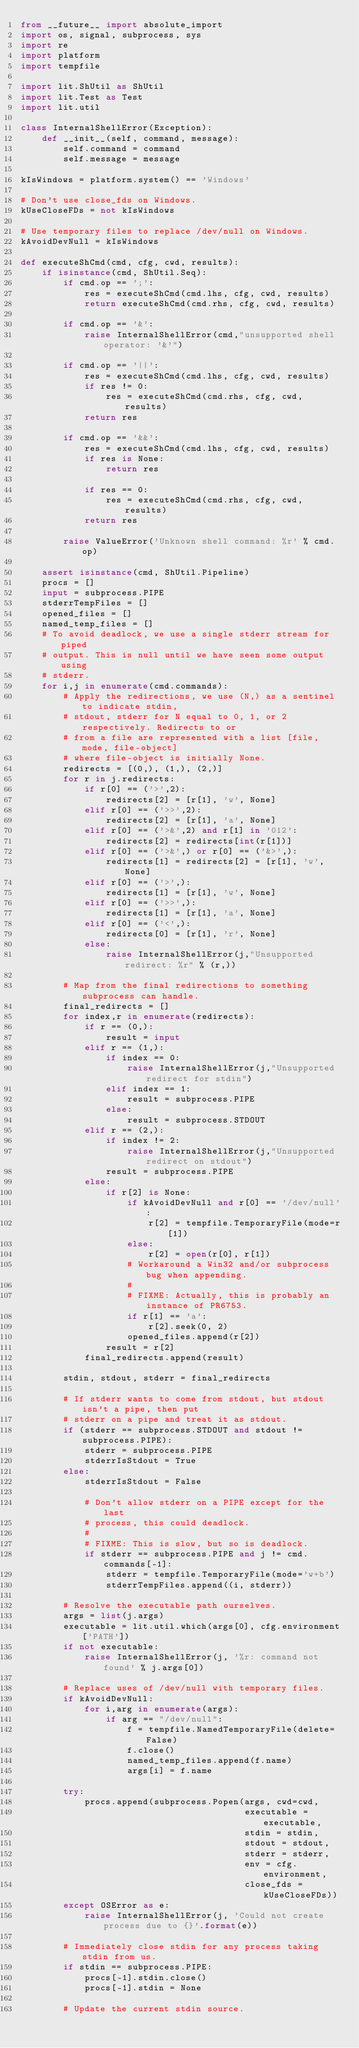<code> <loc_0><loc_0><loc_500><loc_500><_Python_>from __future__ import absolute_import
import os, signal, subprocess, sys
import re
import platform
import tempfile

import lit.ShUtil as ShUtil
import lit.Test as Test
import lit.util

class InternalShellError(Exception):
    def __init__(self, command, message):
        self.command = command
        self.message = message

kIsWindows = platform.system() == 'Windows'

# Don't use close_fds on Windows.
kUseCloseFDs = not kIsWindows

# Use temporary files to replace /dev/null on Windows.
kAvoidDevNull = kIsWindows

def executeShCmd(cmd, cfg, cwd, results):
    if isinstance(cmd, ShUtil.Seq):
        if cmd.op == ';':
            res = executeShCmd(cmd.lhs, cfg, cwd, results)
            return executeShCmd(cmd.rhs, cfg, cwd, results)

        if cmd.op == '&':
            raise InternalShellError(cmd,"unsupported shell operator: '&'")

        if cmd.op == '||':
            res = executeShCmd(cmd.lhs, cfg, cwd, results)
            if res != 0:
                res = executeShCmd(cmd.rhs, cfg, cwd, results)
            return res

        if cmd.op == '&&':
            res = executeShCmd(cmd.lhs, cfg, cwd, results)
            if res is None:
                return res

            if res == 0:
                res = executeShCmd(cmd.rhs, cfg, cwd, results)
            return res

        raise ValueError('Unknown shell command: %r' % cmd.op)

    assert isinstance(cmd, ShUtil.Pipeline)
    procs = []
    input = subprocess.PIPE
    stderrTempFiles = []
    opened_files = []
    named_temp_files = []
    # To avoid deadlock, we use a single stderr stream for piped
    # output. This is null until we have seen some output using
    # stderr.
    for i,j in enumerate(cmd.commands):
        # Apply the redirections, we use (N,) as a sentinel to indicate stdin,
        # stdout, stderr for N equal to 0, 1, or 2 respectively. Redirects to or
        # from a file are represented with a list [file, mode, file-object]
        # where file-object is initially None.
        redirects = [(0,), (1,), (2,)]
        for r in j.redirects:
            if r[0] == ('>',2):
                redirects[2] = [r[1], 'w', None]
            elif r[0] == ('>>',2):
                redirects[2] = [r[1], 'a', None]
            elif r[0] == ('>&',2) and r[1] in '012':
                redirects[2] = redirects[int(r[1])]
            elif r[0] == ('>&',) or r[0] == ('&>',):
                redirects[1] = redirects[2] = [r[1], 'w', None]
            elif r[0] == ('>',):
                redirects[1] = [r[1], 'w', None]
            elif r[0] == ('>>',):
                redirects[1] = [r[1], 'a', None]
            elif r[0] == ('<',):
                redirects[0] = [r[1], 'r', None]
            else:
                raise InternalShellError(j,"Unsupported redirect: %r" % (r,))

        # Map from the final redirections to something subprocess can handle.
        final_redirects = []
        for index,r in enumerate(redirects):
            if r == (0,):
                result = input
            elif r == (1,):
                if index == 0:
                    raise InternalShellError(j,"Unsupported redirect for stdin")
                elif index == 1:
                    result = subprocess.PIPE
                else:
                    result = subprocess.STDOUT
            elif r == (2,):
                if index != 2:
                    raise InternalShellError(j,"Unsupported redirect on stdout")
                result = subprocess.PIPE
            else:
                if r[2] is None:
                    if kAvoidDevNull and r[0] == '/dev/null':
                        r[2] = tempfile.TemporaryFile(mode=r[1])
                    else:
                        r[2] = open(r[0], r[1])
                    # Workaround a Win32 and/or subprocess bug when appending.
                    #
                    # FIXME: Actually, this is probably an instance of PR6753.
                    if r[1] == 'a':
                        r[2].seek(0, 2)
                    opened_files.append(r[2])
                result = r[2]
            final_redirects.append(result)

        stdin, stdout, stderr = final_redirects

        # If stderr wants to come from stdout, but stdout isn't a pipe, then put
        # stderr on a pipe and treat it as stdout.
        if (stderr == subprocess.STDOUT and stdout != subprocess.PIPE):
            stderr = subprocess.PIPE
            stderrIsStdout = True
        else:
            stderrIsStdout = False

            # Don't allow stderr on a PIPE except for the last
            # process, this could deadlock.
            #
            # FIXME: This is slow, but so is deadlock.
            if stderr == subprocess.PIPE and j != cmd.commands[-1]:
                stderr = tempfile.TemporaryFile(mode='w+b')
                stderrTempFiles.append((i, stderr))

        # Resolve the executable path ourselves.
        args = list(j.args)
        executable = lit.util.which(args[0], cfg.environment['PATH'])
        if not executable:
            raise InternalShellError(j, '%r: command not found' % j.args[0])

        # Replace uses of /dev/null with temporary files.
        if kAvoidDevNull:
            for i,arg in enumerate(args):
                if arg == "/dev/null":
                    f = tempfile.NamedTemporaryFile(delete=False)
                    f.close()
                    named_temp_files.append(f.name)
                    args[i] = f.name

        try:
            procs.append(subprocess.Popen(args, cwd=cwd,
                                          executable = executable,
                                          stdin = stdin,
                                          stdout = stdout,
                                          stderr = stderr,
                                          env = cfg.environment,
                                          close_fds = kUseCloseFDs))
        except OSError as e:
            raise InternalShellError(j, 'Could not create process due to {}'.format(e))

        # Immediately close stdin for any process taking stdin from us.
        if stdin == subprocess.PIPE:
            procs[-1].stdin.close()
            procs[-1].stdin = None

        # Update the current stdin source.</code> 